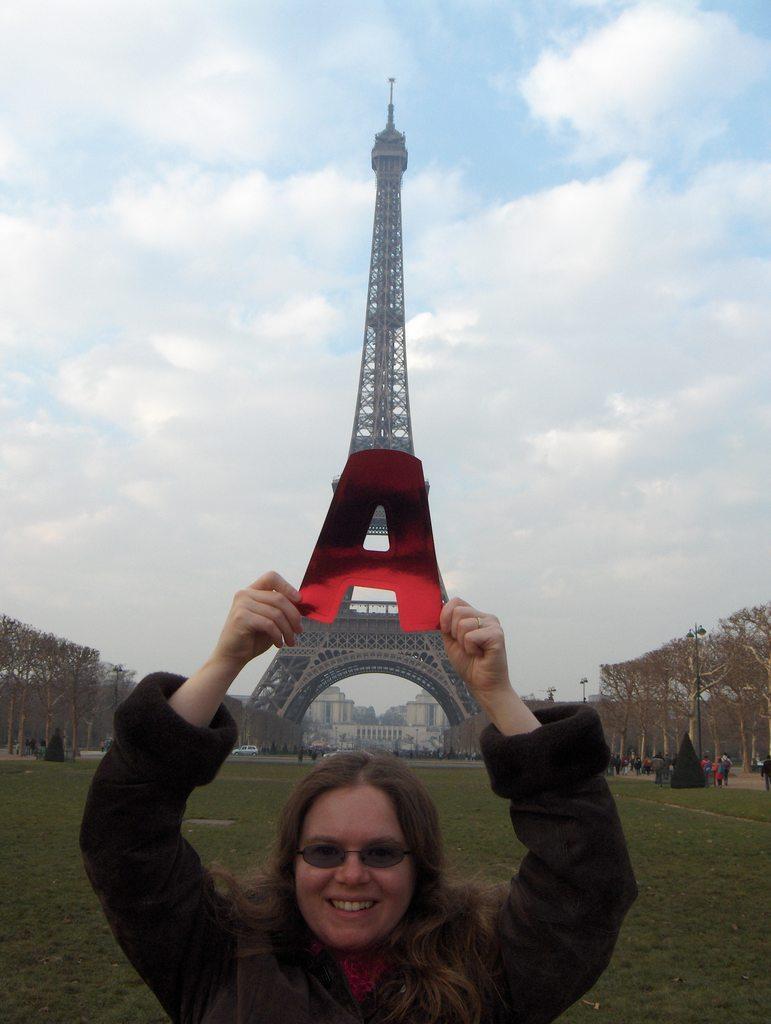How would you summarize this image in a sentence or two? In this image we can see a woman holding an object and in the background, we can see the Eiffel tower and some buildings. We can see a few people and there are some trees an at the top we can see the sky with clouds. 